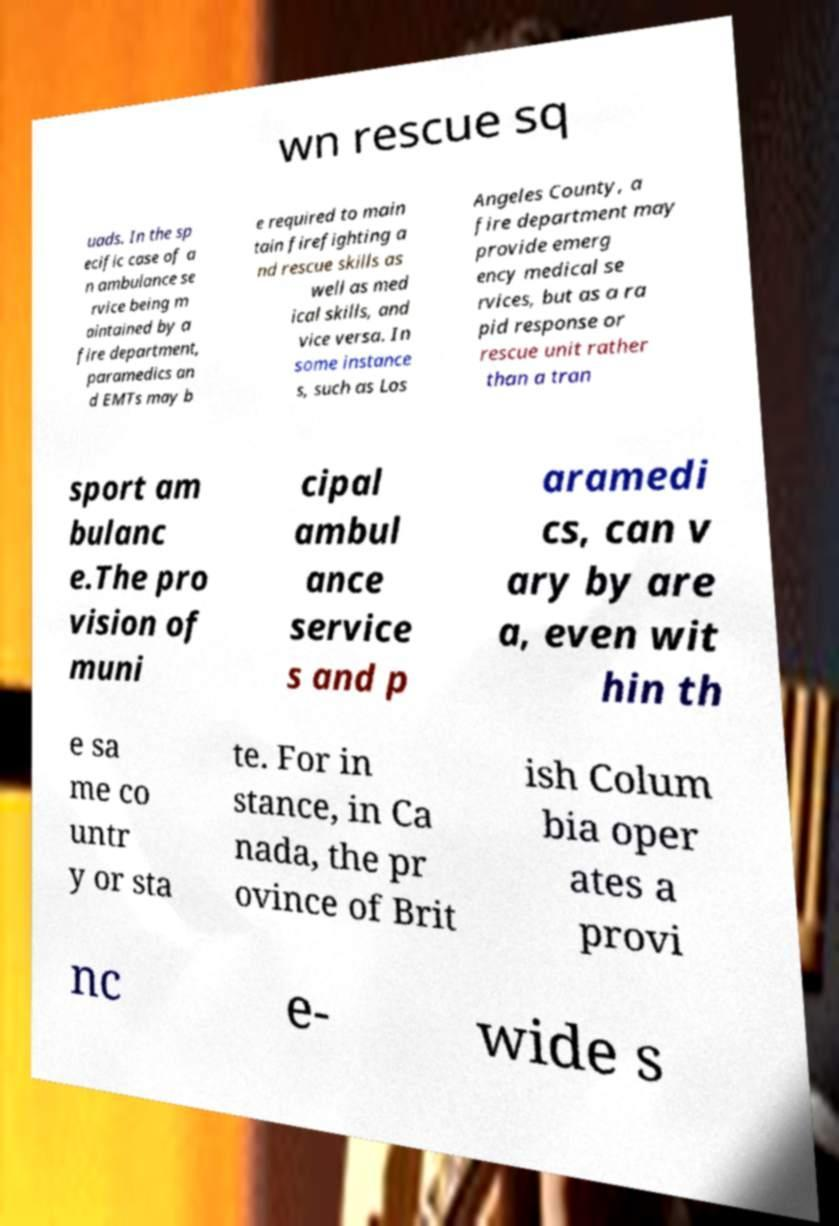Please identify and transcribe the text found in this image. wn rescue sq uads. In the sp ecific case of a n ambulance se rvice being m aintained by a fire department, paramedics an d EMTs may b e required to main tain firefighting a nd rescue skills as well as med ical skills, and vice versa. In some instance s, such as Los Angeles County, a fire department may provide emerg ency medical se rvices, but as a ra pid response or rescue unit rather than a tran sport am bulanc e.The pro vision of muni cipal ambul ance service s and p aramedi cs, can v ary by are a, even wit hin th e sa me co untr y or sta te. For in stance, in Ca nada, the pr ovince of Brit ish Colum bia oper ates a provi nc e- wide s 